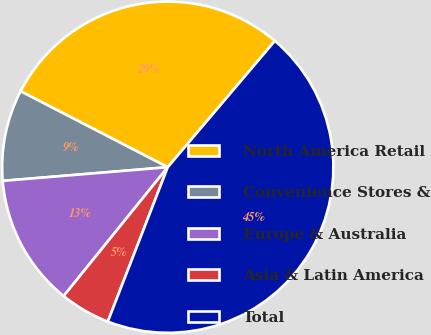Convert chart. <chart><loc_0><loc_0><loc_500><loc_500><pie_chart><fcel>North America Retail<fcel>Convenience Stores &<fcel>Europe & Australia<fcel>Asia & Latin America<fcel>Total<nl><fcel>28.61%<fcel>8.9%<fcel>12.87%<fcel>4.92%<fcel>44.7%<nl></chart> 